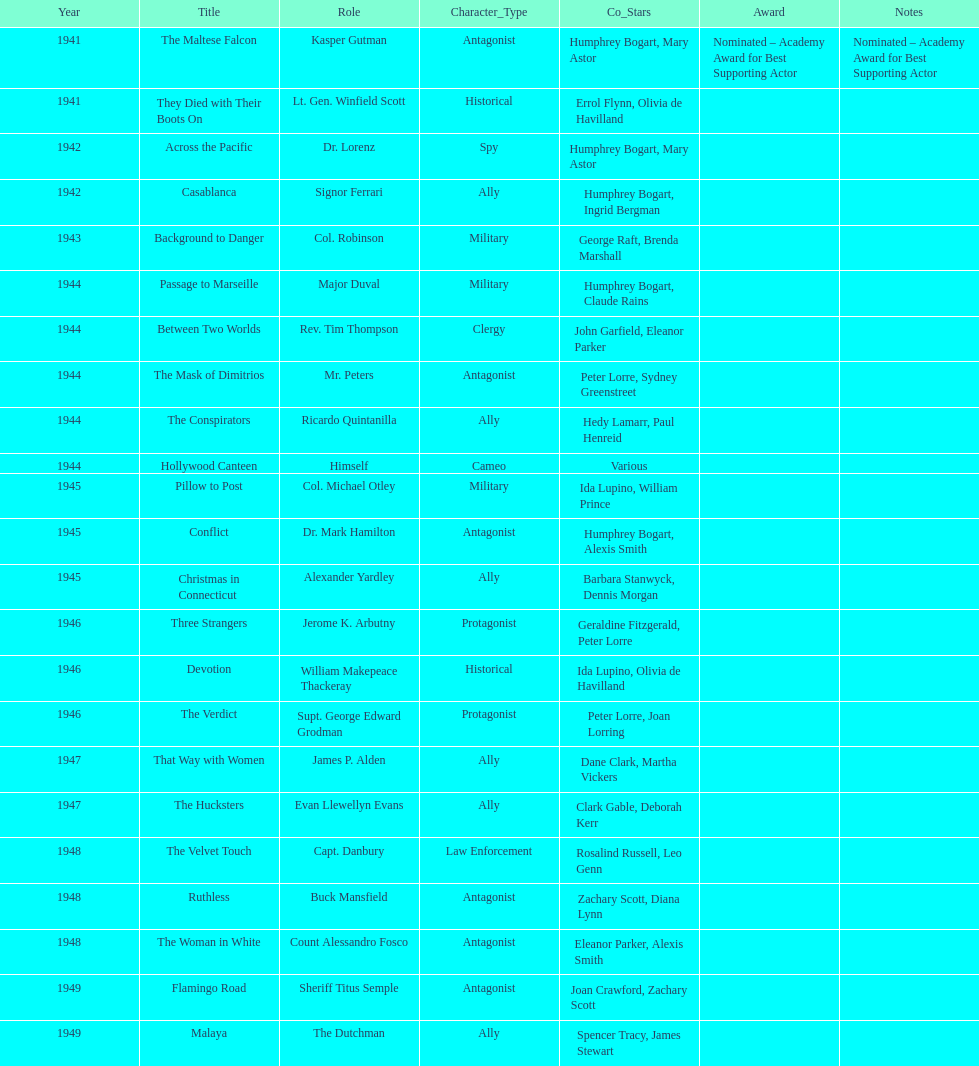What were the first and last movies greenstreet acted in? The Maltese Falcon, Malaya. 